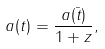Convert formula to latex. <formula><loc_0><loc_0><loc_500><loc_500>a ( t ) = \frac { a ( \bar { t } ) } { 1 + z } ,</formula> 